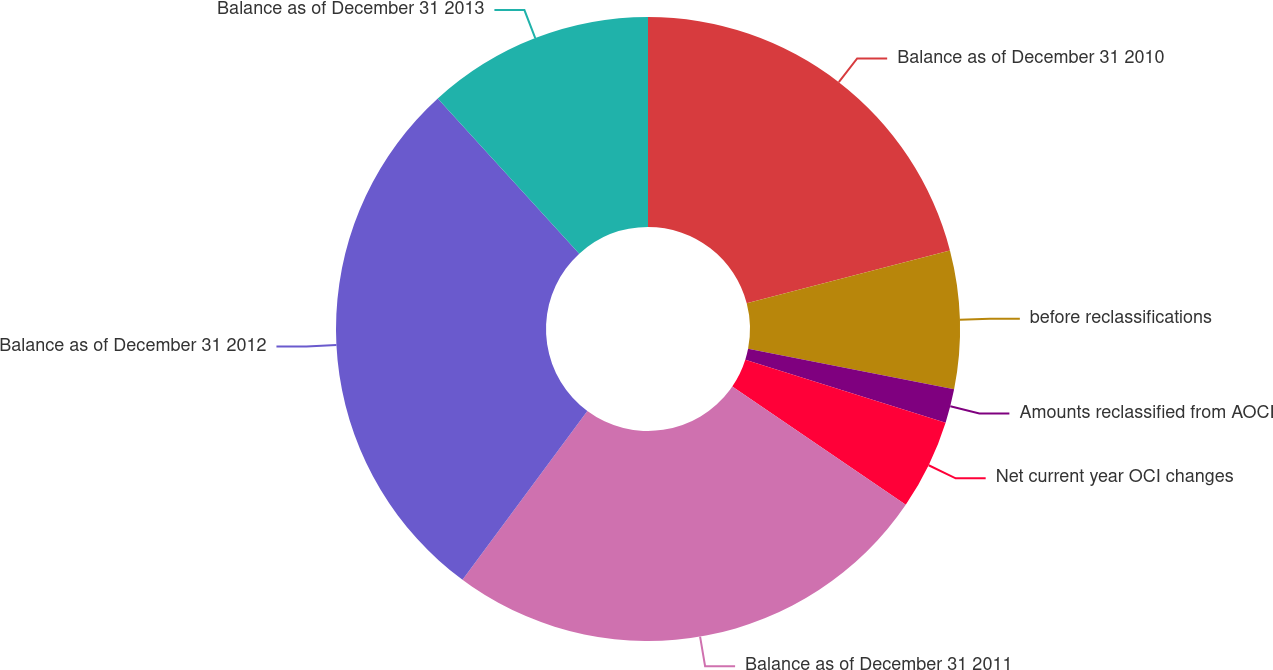<chart> <loc_0><loc_0><loc_500><loc_500><pie_chart><fcel>Balance as of December 31 2010<fcel>before reclassifications<fcel>Amounts reclassified from AOCI<fcel>Net current year OCI changes<fcel>Balance as of December 31 2011<fcel>Balance as of December 31 2012<fcel>Balance as of December 31 2013<nl><fcel>20.95%<fcel>7.15%<fcel>1.76%<fcel>4.67%<fcel>25.61%<fcel>28.1%<fcel>11.77%<nl></chart> 